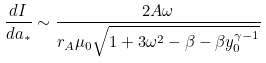Convert formula to latex. <formula><loc_0><loc_0><loc_500><loc_500>\frac { d I } { d a _ { * } } \sim \frac { 2 A \omega } { r _ { A } \mu _ { 0 } \sqrt { 1 + 3 \omega ^ { 2 } - \beta - \beta y _ { 0 } ^ { \gamma - 1 } } }</formula> 